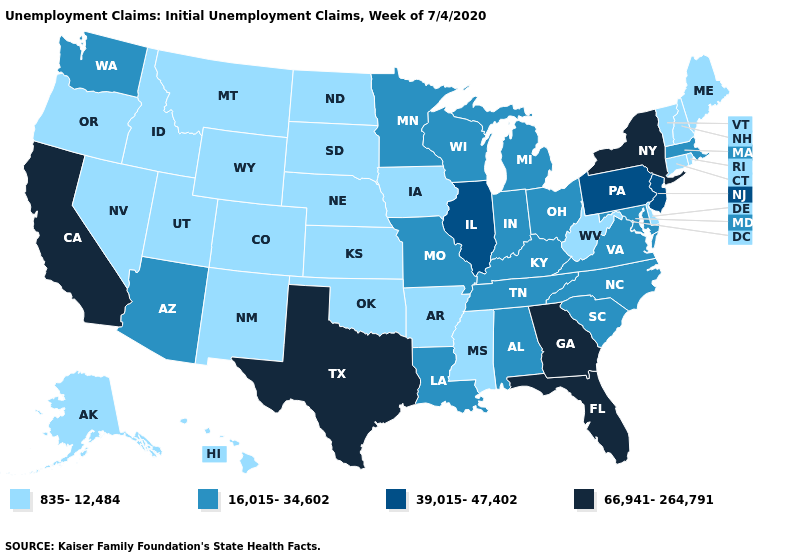What is the lowest value in the Northeast?
Give a very brief answer. 835-12,484. What is the value of Illinois?
Give a very brief answer. 39,015-47,402. Does the first symbol in the legend represent the smallest category?
Quick response, please. Yes. Does Michigan have the lowest value in the USA?
Write a very short answer. No. Which states have the lowest value in the West?
Concise answer only. Alaska, Colorado, Hawaii, Idaho, Montana, Nevada, New Mexico, Oregon, Utah, Wyoming. Name the states that have a value in the range 16,015-34,602?
Short answer required. Alabama, Arizona, Indiana, Kentucky, Louisiana, Maryland, Massachusetts, Michigan, Minnesota, Missouri, North Carolina, Ohio, South Carolina, Tennessee, Virginia, Washington, Wisconsin. What is the highest value in states that border South Dakota?
Quick response, please. 16,015-34,602. Name the states that have a value in the range 66,941-264,791?
Answer briefly. California, Florida, Georgia, New York, Texas. Does the map have missing data?
Keep it brief. No. Among the states that border New Jersey , does Delaware have the lowest value?
Give a very brief answer. Yes. Does Texas have the highest value in the South?
Be succinct. Yes. Is the legend a continuous bar?
Answer briefly. No. Does Arizona have the lowest value in the West?
Be succinct. No. Name the states that have a value in the range 16,015-34,602?
Answer briefly. Alabama, Arizona, Indiana, Kentucky, Louisiana, Maryland, Massachusetts, Michigan, Minnesota, Missouri, North Carolina, Ohio, South Carolina, Tennessee, Virginia, Washington, Wisconsin. Does Virginia have a lower value than California?
Give a very brief answer. Yes. 